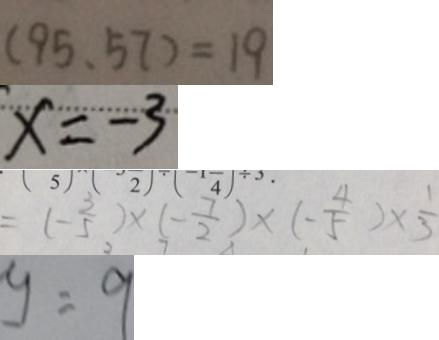<formula> <loc_0><loc_0><loc_500><loc_500>( 9 5 , 5 7 ) = 1 9 
 x = - 3 
 = ( - \frac { 3 } { 5 } ) \times ( - \frac { 7 } { 2 } ) \times ( - \frac { 4 } { 5 } ) \times \frac { 1 } { 3 } 
 y = 9</formula> 